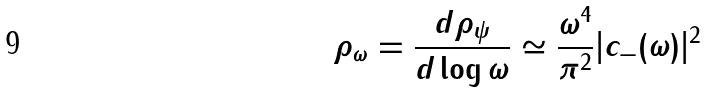Convert formula to latex. <formula><loc_0><loc_0><loc_500><loc_500>\rho _ { \omega } = \frac { d \rho _ { \psi } } { d \log { \omega } } \simeq \frac { \omega ^ { 4 } } { \pi ^ { 2 } } | c _ { - } ( \omega ) | ^ { 2 }</formula> 